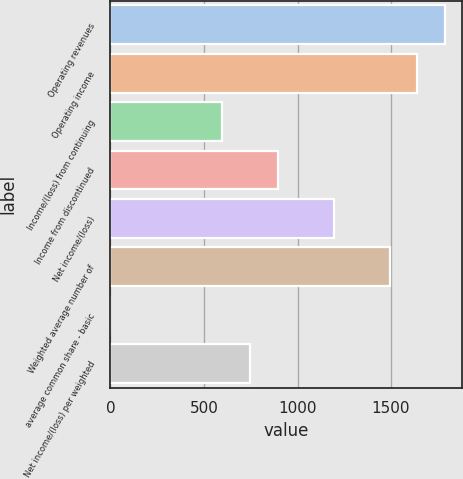<chart> <loc_0><loc_0><loc_500><loc_500><bar_chart><fcel>Operating revenues<fcel>Operating income<fcel>Income/(loss) from continuing<fcel>Income from discontinued<fcel>Net income/(loss)<fcel>Weighted average number of<fcel>average common share - basic<fcel>Net income/(loss) per weighted<nl><fcel>1790.42<fcel>1641.22<fcel>596.82<fcel>895.22<fcel>1193.62<fcel>1492.02<fcel>0.02<fcel>746.02<nl></chart> 